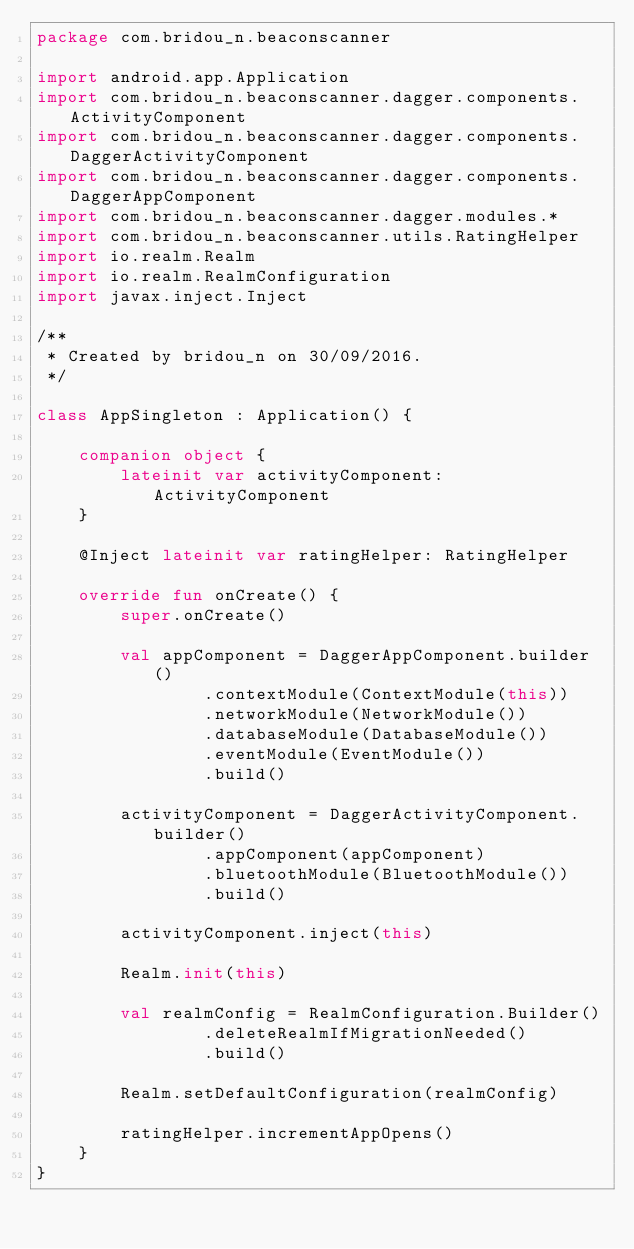Convert code to text. <code><loc_0><loc_0><loc_500><loc_500><_Kotlin_>package com.bridou_n.beaconscanner

import android.app.Application
import com.bridou_n.beaconscanner.dagger.components.ActivityComponent
import com.bridou_n.beaconscanner.dagger.components.DaggerActivityComponent
import com.bridou_n.beaconscanner.dagger.components.DaggerAppComponent
import com.bridou_n.beaconscanner.dagger.modules.*
import com.bridou_n.beaconscanner.utils.RatingHelper
import io.realm.Realm
import io.realm.RealmConfiguration
import javax.inject.Inject

/**
 * Created by bridou_n on 30/09/2016.
 */

class AppSingleton : Application() {

    companion object {
        lateinit var activityComponent: ActivityComponent
    }

    @Inject lateinit var ratingHelper: RatingHelper

    override fun onCreate() {
        super.onCreate()

        val appComponent = DaggerAppComponent.builder()
                .contextModule(ContextModule(this))
                .networkModule(NetworkModule())
                .databaseModule(DatabaseModule())
                .eventModule(EventModule())
                .build()

        activityComponent = DaggerActivityComponent.builder()
                .appComponent(appComponent)
                .bluetoothModule(BluetoothModule())
                .build()

        activityComponent.inject(this)

        Realm.init(this)

        val realmConfig = RealmConfiguration.Builder()
                .deleteRealmIfMigrationNeeded()
                .build()

        Realm.setDefaultConfiguration(realmConfig)

        ratingHelper.incrementAppOpens()
    }
}
</code> 